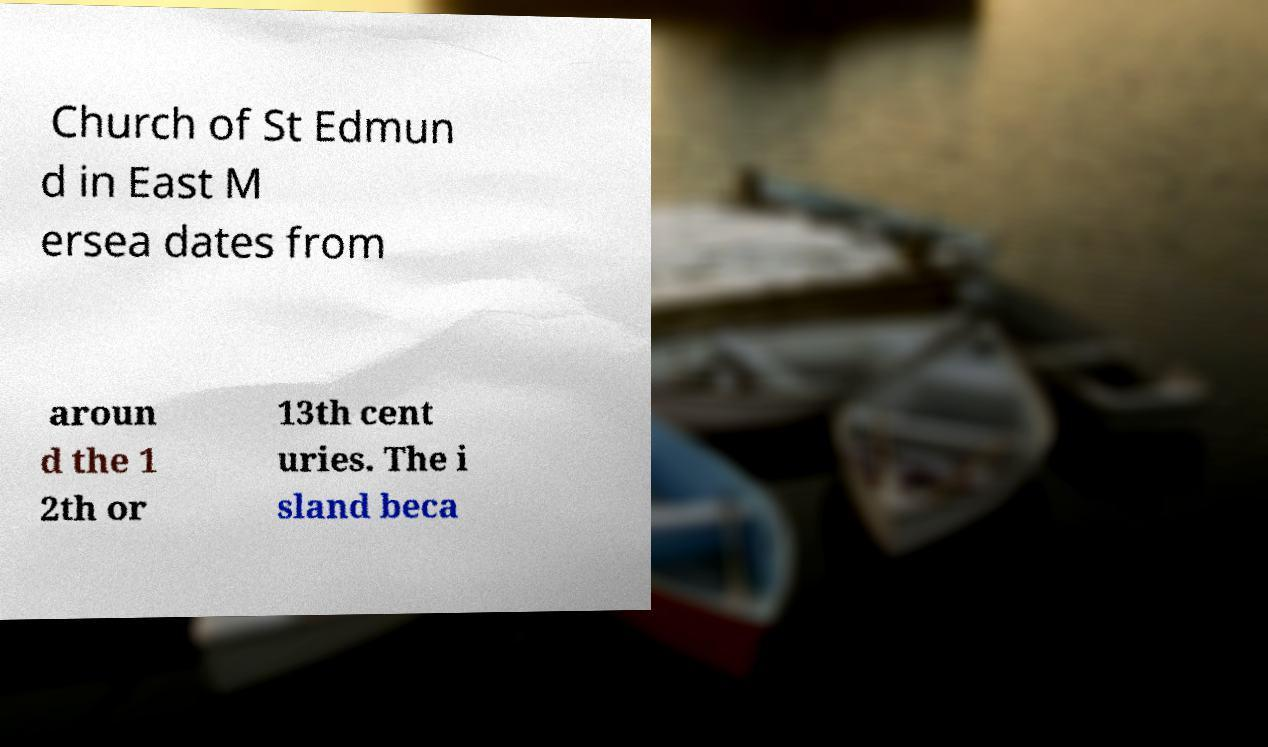For documentation purposes, I need the text within this image transcribed. Could you provide that? Church of St Edmun d in East M ersea dates from aroun d the 1 2th or 13th cent uries. The i sland beca 